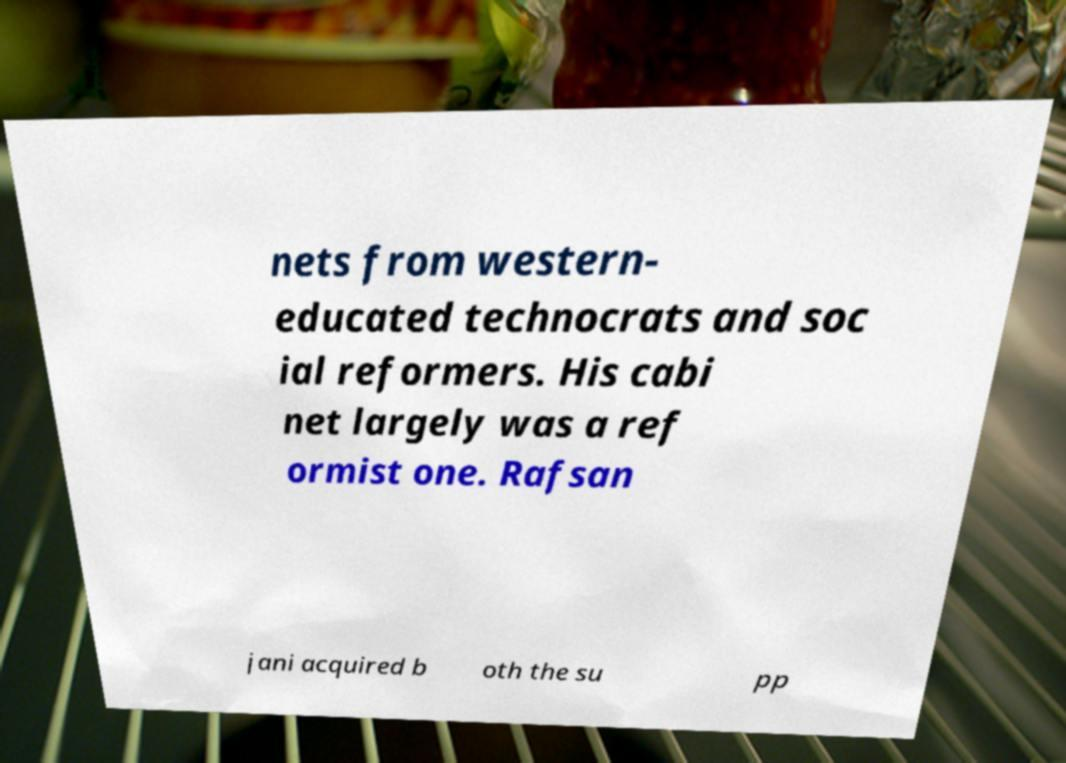I need the written content from this picture converted into text. Can you do that? nets from western- educated technocrats and soc ial reformers. His cabi net largely was a ref ormist one. Rafsan jani acquired b oth the su pp 